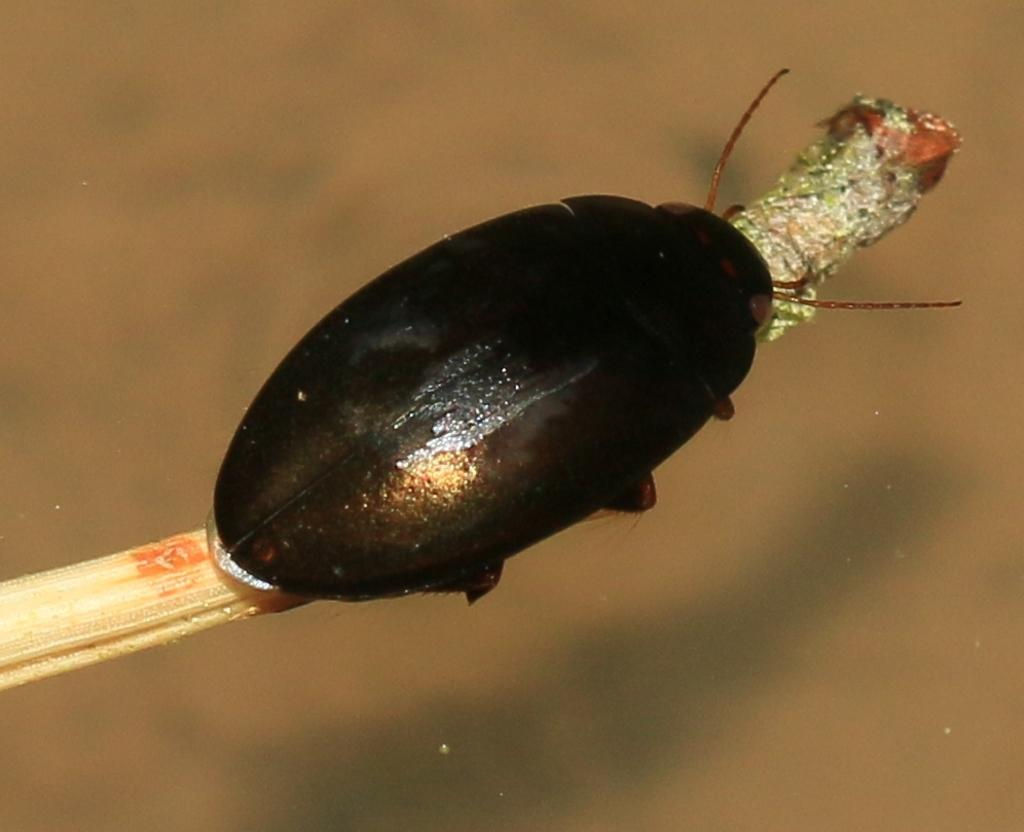What is present in the picture? There is an insect in the picture. Where is the insect located? The insect is on a stick. What is the color of the insect? The insect is black in color. What type of jeans is the insect wearing in the image? There is no indication that the insect is wearing jeans or any clothing in the image. 